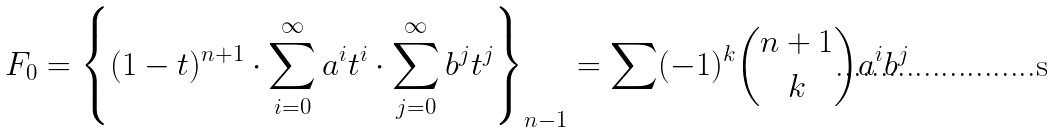Convert formula to latex. <formula><loc_0><loc_0><loc_500><loc_500>F _ { 0 } & = \left \{ ( 1 - t ) ^ { n + 1 } \cdot \sum _ { i = 0 } ^ { \infty } a ^ { i } t ^ { i } \cdot \sum _ { j = 0 } ^ { \infty } b ^ { j } t ^ { j } \right \} _ { n - 1 } = \sum ( - 1 ) ^ { k } \binom { n + 1 } { k } a ^ { i } b ^ { j }</formula> 